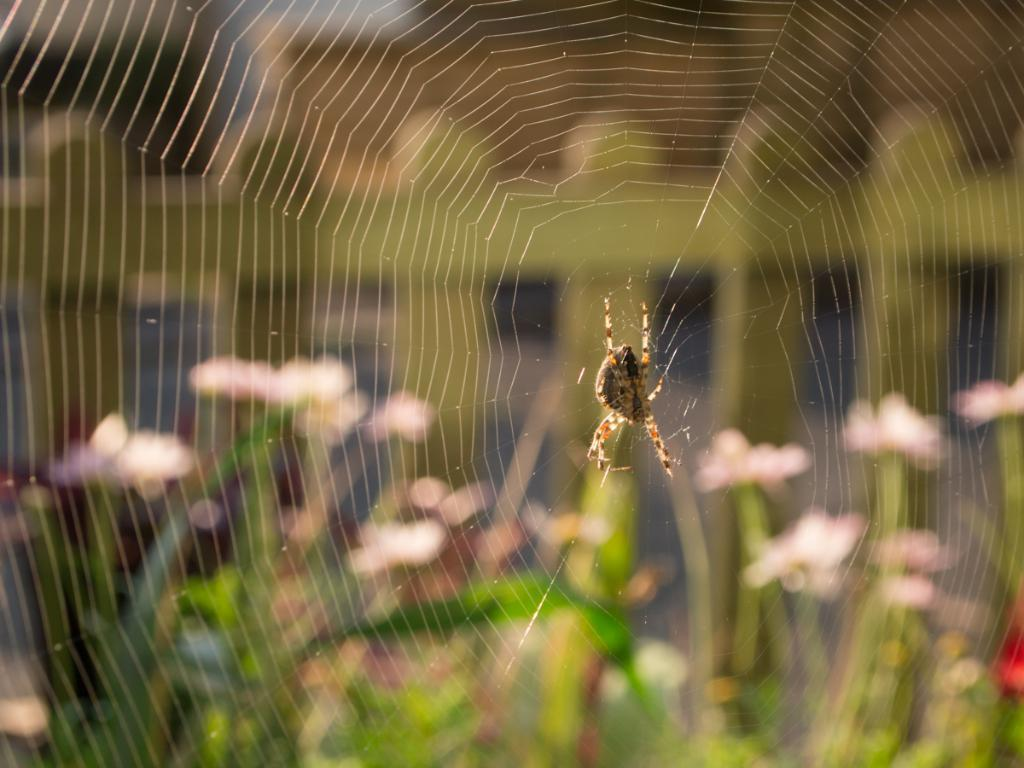What is the main subject of the image? There is a spider in the image. Where is the spider located? The spider is on a web. Can you describe the background of the image? The background of the image is blurred. What type of calculator can be seen in the image? There is no calculator present in the image. How does the spider increase its size in the image? The spider does not increase its size in the image; it is already on the web. 